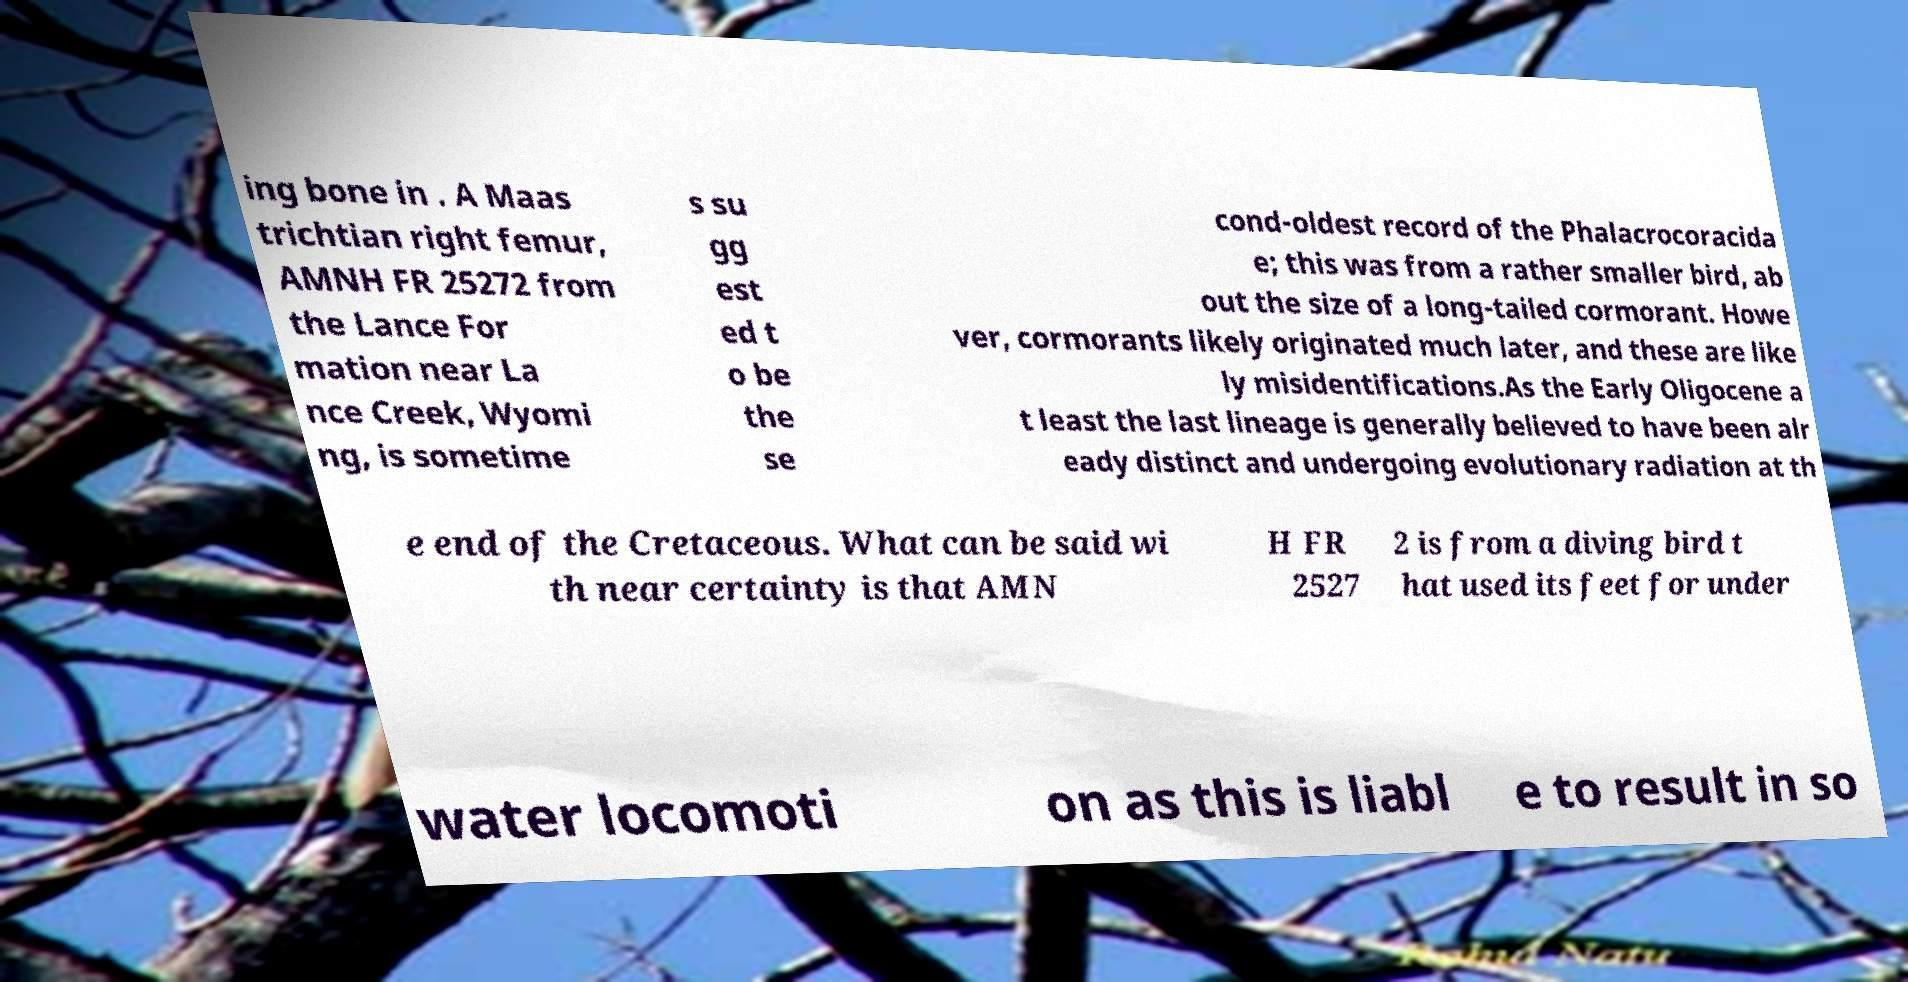Can you accurately transcribe the text from the provided image for me? ing bone in . A Maas trichtian right femur, AMNH FR 25272 from the Lance For mation near La nce Creek, Wyomi ng, is sometime s su gg est ed t o be the se cond-oldest record of the Phalacrocoracida e; this was from a rather smaller bird, ab out the size of a long-tailed cormorant. Howe ver, cormorants likely originated much later, and these are like ly misidentifications.As the Early Oligocene a t least the last lineage is generally believed to have been alr eady distinct and undergoing evolutionary radiation at th e end of the Cretaceous. What can be said wi th near certainty is that AMN H FR 2527 2 is from a diving bird t hat used its feet for under water locomoti on as this is liabl e to result in so 